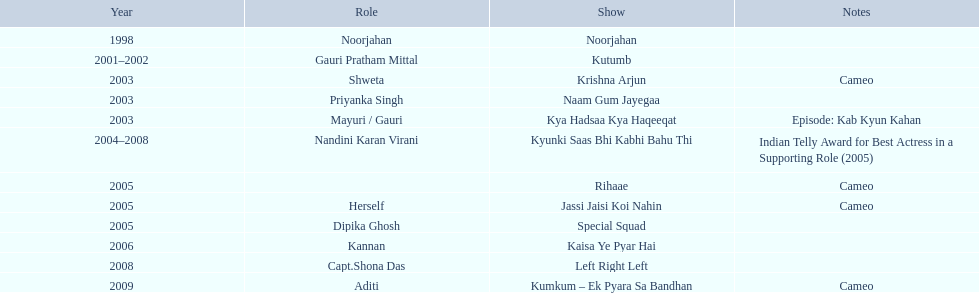Which one television program featured gauri playing her own character? Jassi Jaisi Koi Nahin. 